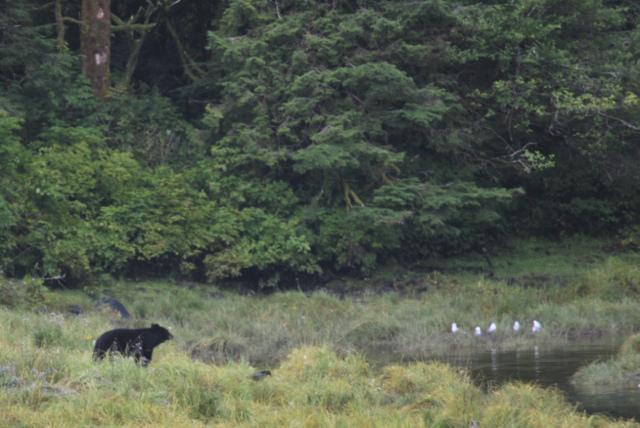Is this scene "dry"?
Answer briefly. No. What is the bear doing?
Short answer required. Walking. Are these animals in an enclosure?
Concise answer only. No. Is this a bird or mammal?
Give a very brief answer. Mammal. Does this animal look dangerous?
Keep it brief. Yes. Where do these animals live?
Write a very short answer. Wild. What animal is this?
Short answer required. Bear. Are the animals in their natural habitat?
Keep it brief. Yes. Is there a dog in this image?
Short answer required. No. Where are the trees?
Keep it brief. Forest. Is the water going to save the birds?
Write a very short answer. No. How many birds are pictured?
Keep it brief. 5. Is there a body of water visible?
Short answer required. Yes. Are any of the animals pictured predators among their prey?
Short answer required. Yes. What color are those birds?
Concise answer only. White. Can you see through the forest?
Answer briefly. No. What is the bear looking at?
Quick response, please. Birds. What animals are in the background?
Keep it brief. Bear. What is the animal eating?
Short answer required. Nothing. What in this photo could this animal eat?
Short answer required. Birds. 